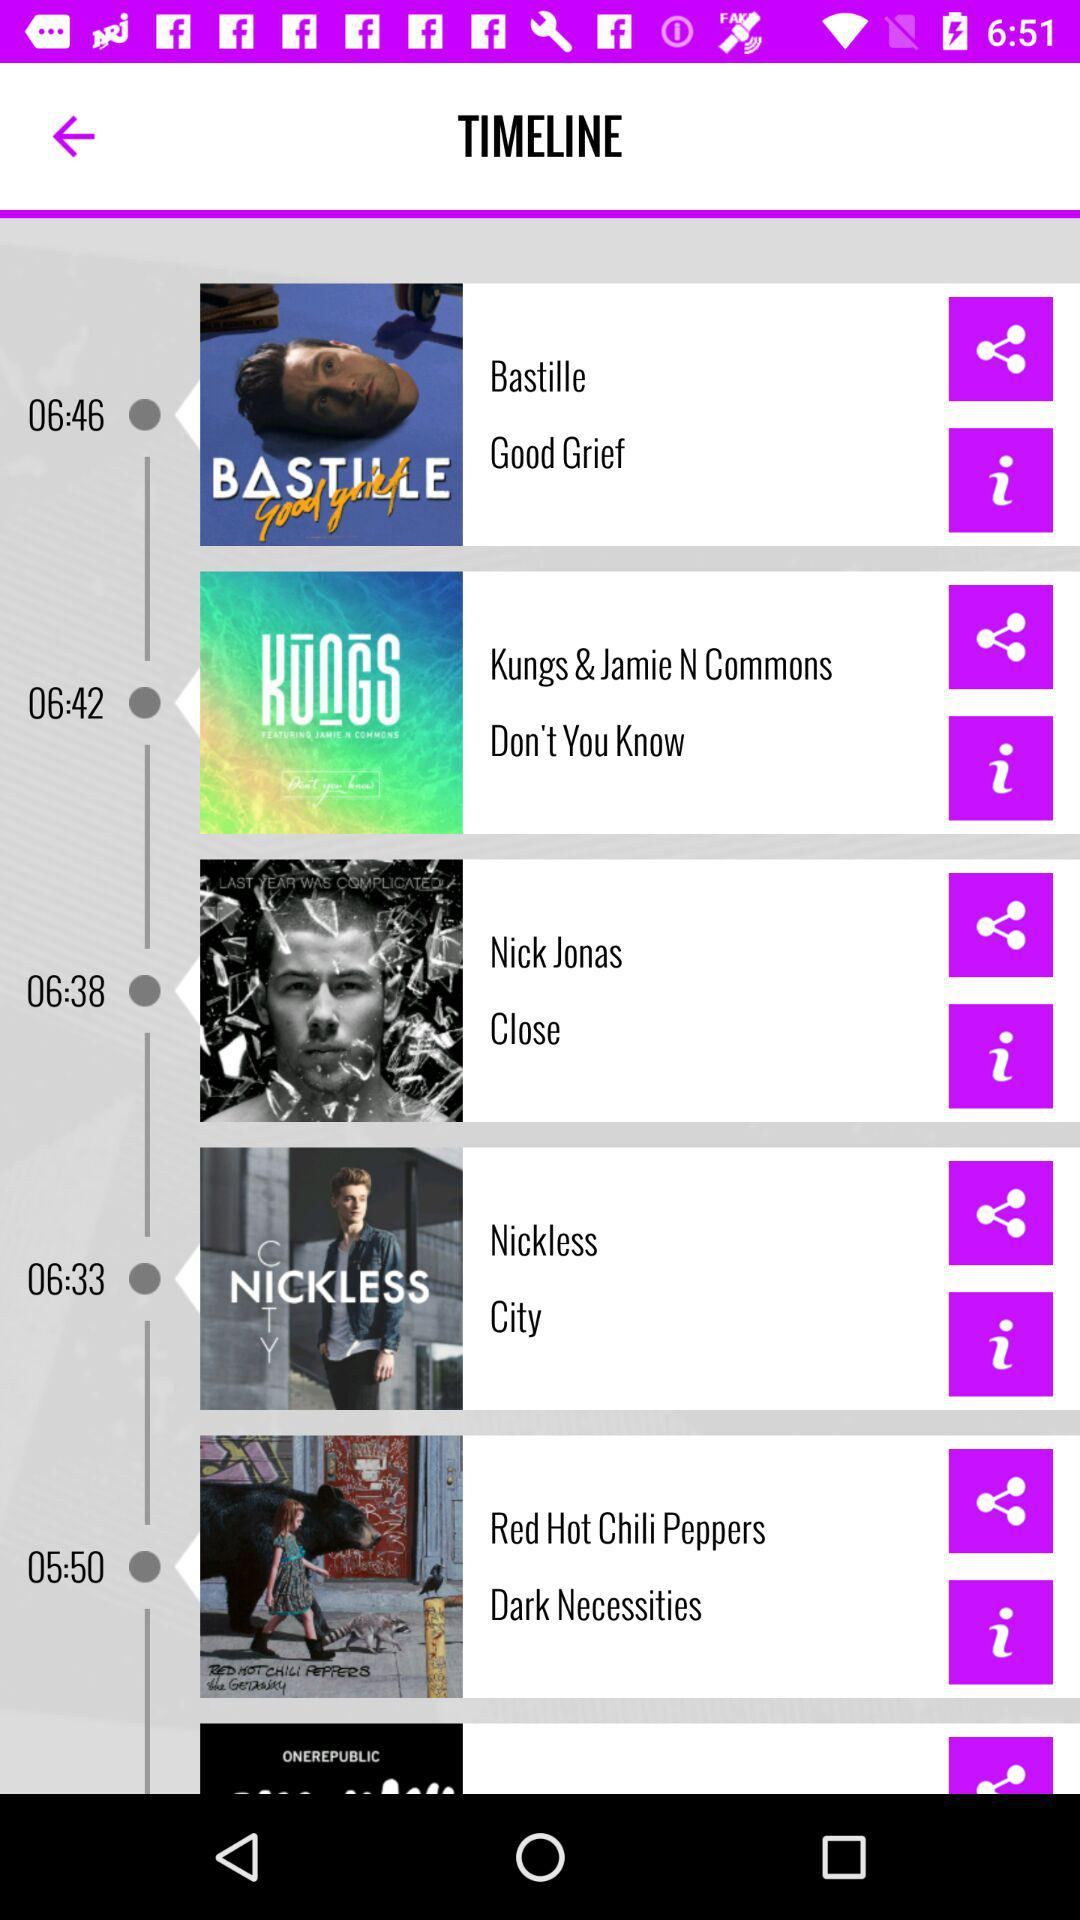What is the title of the song whose time is 05:50 on the timeline? The title of the song is "Dark Necessities". 